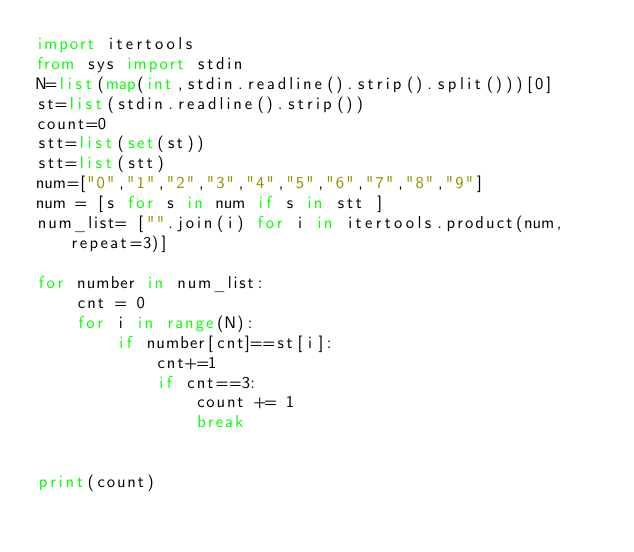<code> <loc_0><loc_0><loc_500><loc_500><_Python_>import itertools
from sys import stdin
N=list(map(int,stdin.readline().strip().split()))[0]
st=list(stdin.readline().strip())
count=0
stt=list(set(st))
stt=list(stt)
num=["0","1","2","3","4","5","6","7","8","9"]
num = [s for s in num if s in stt ]
num_list= ["".join(i) for i in itertools.product(num,repeat=3)]

for number in num_list:
    cnt = 0
    for i in range(N):
        if number[cnt]==st[i]:
            cnt+=1
            if cnt==3:
                count += 1
                break


print(count)</code> 